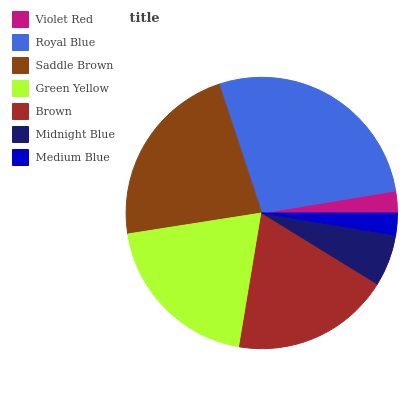Is Violet Red the minimum?
Answer yes or no. Yes. Is Royal Blue the maximum?
Answer yes or no. Yes. Is Saddle Brown the minimum?
Answer yes or no. No. Is Saddle Brown the maximum?
Answer yes or no. No. Is Royal Blue greater than Saddle Brown?
Answer yes or no. Yes. Is Saddle Brown less than Royal Blue?
Answer yes or no. Yes. Is Saddle Brown greater than Royal Blue?
Answer yes or no. No. Is Royal Blue less than Saddle Brown?
Answer yes or no. No. Is Brown the high median?
Answer yes or no. Yes. Is Brown the low median?
Answer yes or no. Yes. Is Royal Blue the high median?
Answer yes or no. No. Is Saddle Brown the low median?
Answer yes or no. No. 